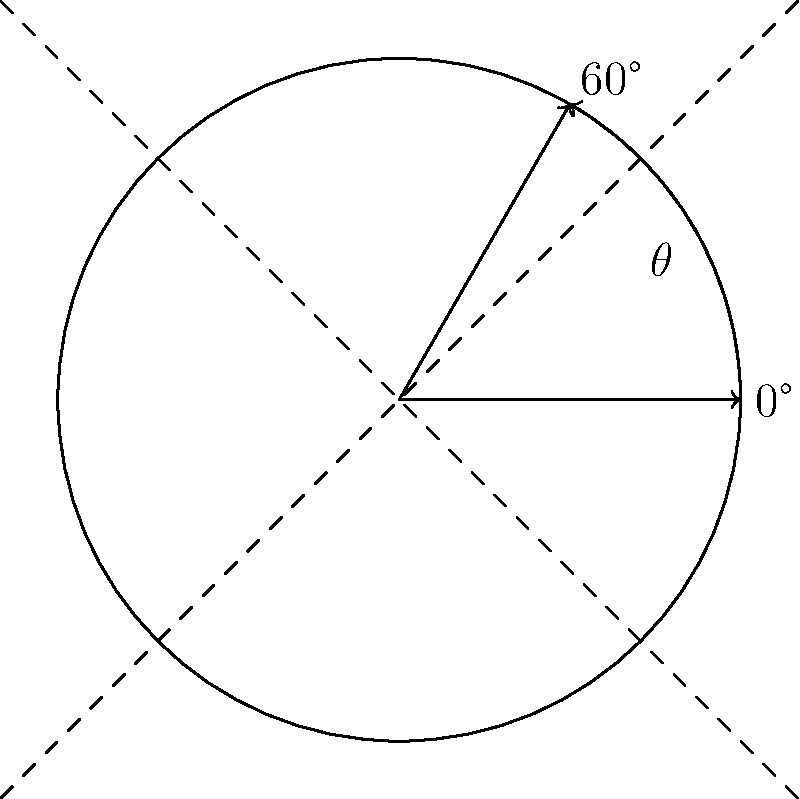You've just scored a pristine vintage turntable at your favorite record shop. As you're setting it up in your retro-inspired listening nook, you decide to rotate it for optimal aesthetic placement. If you rotate the turntable counterclockwise by an angle $\theta$, and then rotate it clockwise by $60°$, it returns to its original position. What is the value of $\theta$? Let's approach this step-by-step:

1) First, let's consider the net rotation. If rotating by $\theta$ counterclockwise and then 60° clockwise brings the turntable back to its original position, the net rotation must be 0°.

2) We can express this mathematically:
   $\theta$ (counterclockwise) - 60° (clockwise) = 0°

3) In rotational geometry, counterclockwise rotations are typically considered positive, while clockwise rotations are negative. So we can rewrite our equation:
   $\theta - (-60°) = 0°$

4) Simplifying:
   $\theta + 60° = 0°$

5) Solving for $\theta$:
   $\theta = -60°$

6) However, the question asks for the counterclockwise rotation. A counterclockwise rotation of 60° is equivalent to a clockwise rotation of -60°.

Therefore, the value of $\theta$ is 60°.
Answer: 60° 